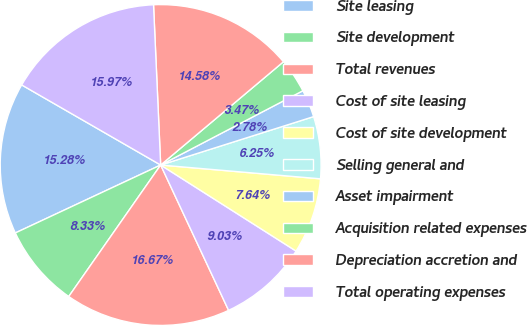<chart> <loc_0><loc_0><loc_500><loc_500><pie_chart><fcel>Site leasing<fcel>Site development<fcel>Total revenues<fcel>Cost of site leasing<fcel>Cost of site development<fcel>Selling general and<fcel>Asset impairment<fcel>Acquisition related expenses<fcel>Depreciation accretion and<fcel>Total operating expenses<nl><fcel>15.28%<fcel>8.33%<fcel>16.67%<fcel>9.03%<fcel>7.64%<fcel>6.25%<fcel>2.78%<fcel>3.47%<fcel>14.58%<fcel>15.97%<nl></chart> 